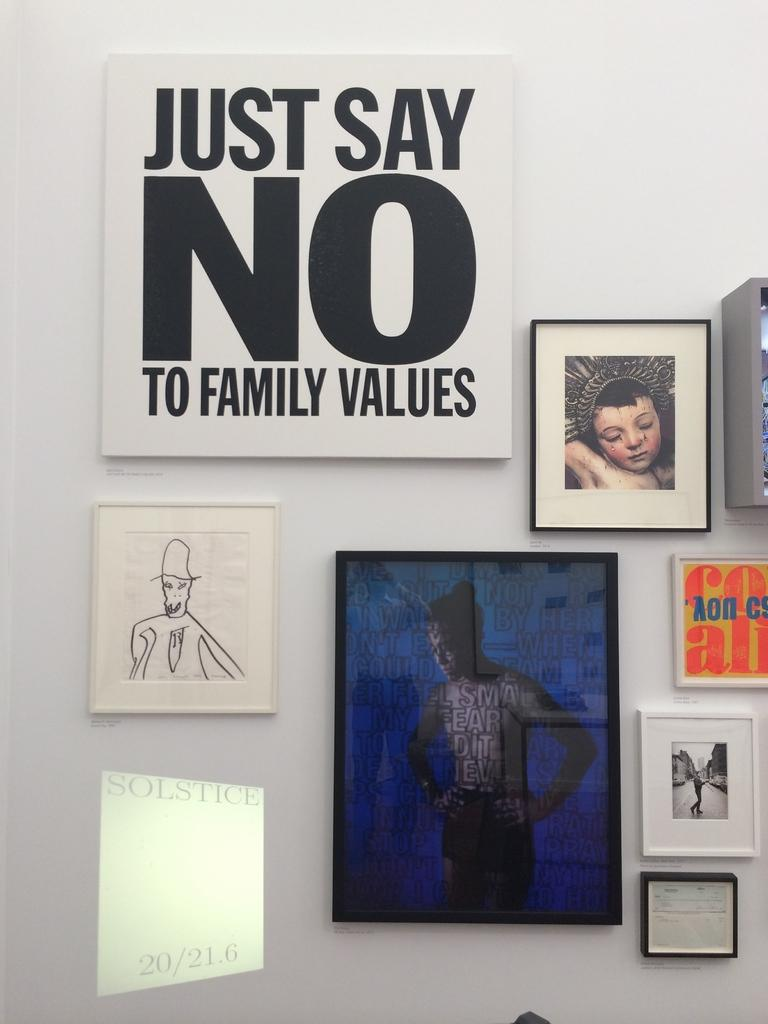What is the main feature of the image? There is a wall in the picture. What is attached to the wall? There are many frames present on the wall. Is there any text visible in the image? Yes, there is some text present in the image. How many passengers are visible in the image? There are no passengers present in the image; it only features a wall with frames and some text. What type of muscle can be seen flexing in the image? There is no muscle visible in the image, as it only features a wall with frames and some text. 